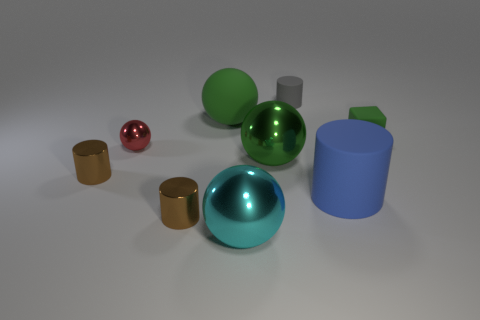Subtract all large green shiny balls. How many balls are left? 3 Add 1 small green matte objects. How many objects exist? 10 Subtract all green spheres. How many spheres are left? 2 Subtract all cubes. How many objects are left? 8 Subtract 1 gray cylinders. How many objects are left? 8 Subtract 1 cubes. How many cubes are left? 0 Subtract all blue blocks. Subtract all cyan cylinders. How many blocks are left? 1 Subtract all green spheres. How many brown cylinders are left? 2 Subtract all cyan shiny objects. Subtract all big blue cylinders. How many objects are left? 7 Add 4 tiny red metallic spheres. How many tiny red metallic spheres are left? 5 